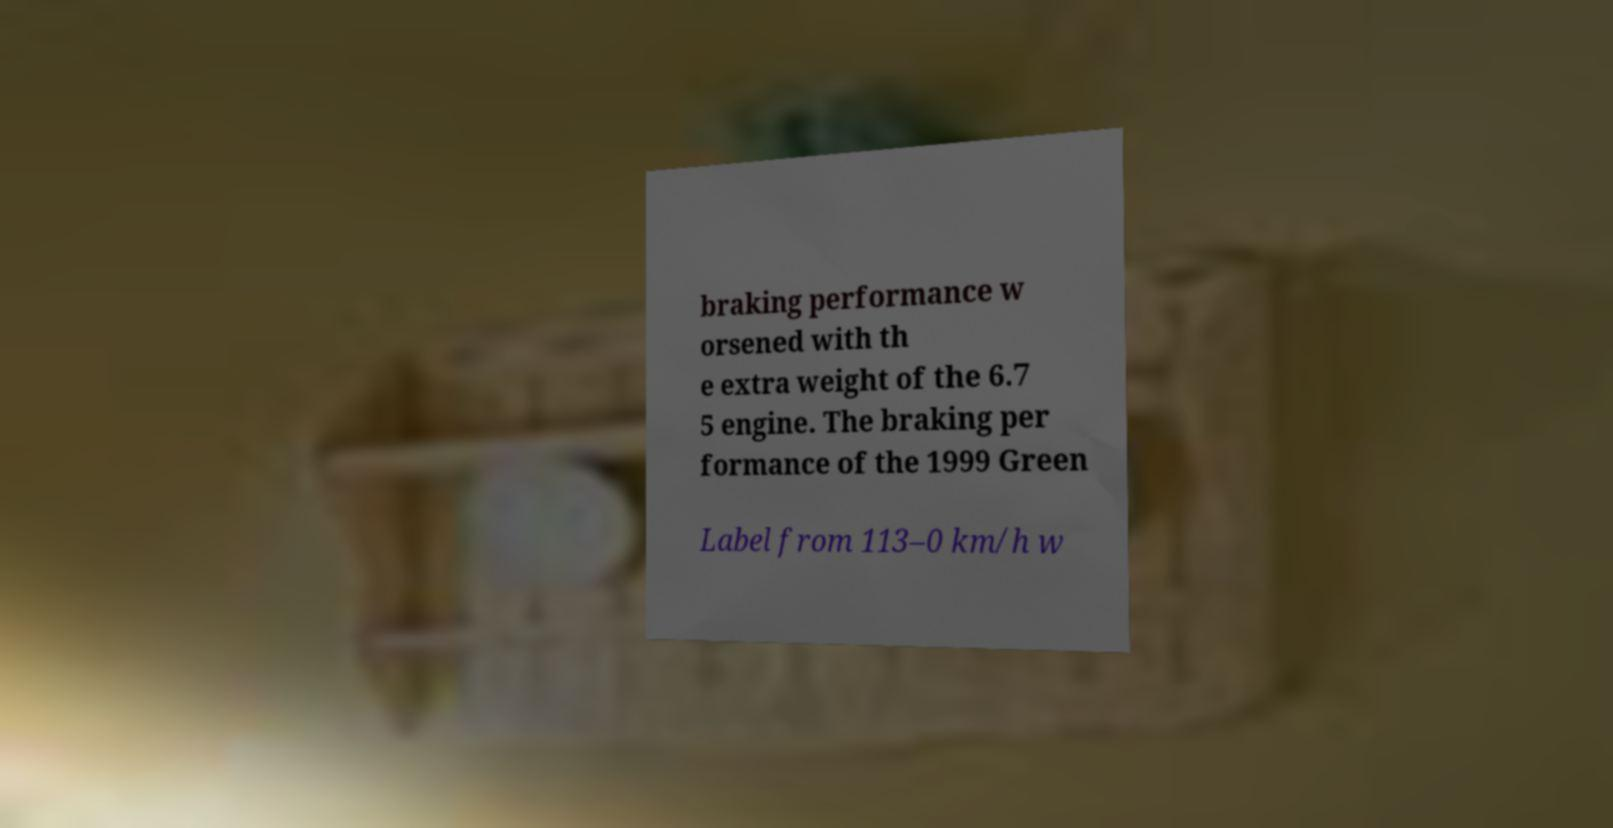Please read and relay the text visible in this image. What does it say? braking performance w orsened with th e extra weight of the 6.7 5 engine. The braking per formance of the 1999 Green Label from 113–0 km/h w 